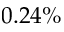<formula> <loc_0><loc_0><loc_500><loc_500>0 . 2 4 \%</formula> 